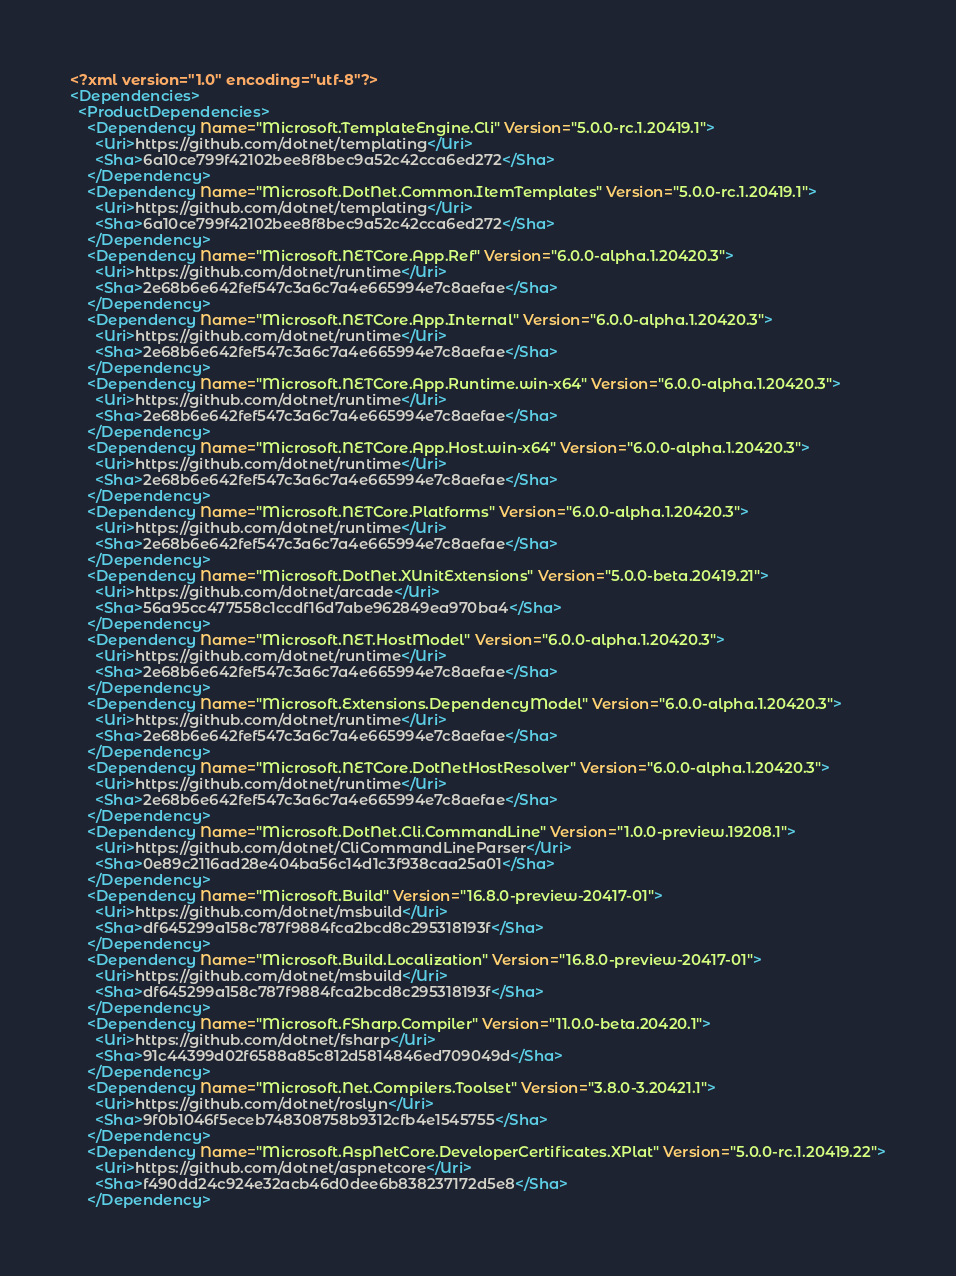<code> <loc_0><loc_0><loc_500><loc_500><_XML_><?xml version="1.0" encoding="utf-8"?>
<Dependencies>
  <ProductDependencies>
    <Dependency Name="Microsoft.TemplateEngine.Cli" Version="5.0.0-rc.1.20419.1">
      <Uri>https://github.com/dotnet/templating</Uri>
      <Sha>6a10ce799f42102bee8f8bec9a52c42cca6ed272</Sha>
    </Dependency>
    <Dependency Name="Microsoft.DotNet.Common.ItemTemplates" Version="5.0.0-rc.1.20419.1">
      <Uri>https://github.com/dotnet/templating</Uri>
      <Sha>6a10ce799f42102bee8f8bec9a52c42cca6ed272</Sha>
    </Dependency>
    <Dependency Name="Microsoft.NETCore.App.Ref" Version="6.0.0-alpha.1.20420.3">
      <Uri>https://github.com/dotnet/runtime</Uri>
      <Sha>2e68b6e642fef547c3a6c7a4e665994e7c8aefae</Sha>
    </Dependency>
    <Dependency Name="Microsoft.NETCore.App.Internal" Version="6.0.0-alpha.1.20420.3">
      <Uri>https://github.com/dotnet/runtime</Uri>
      <Sha>2e68b6e642fef547c3a6c7a4e665994e7c8aefae</Sha>
    </Dependency>
    <Dependency Name="Microsoft.NETCore.App.Runtime.win-x64" Version="6.0.0-alpha.1.20420.3">
      <Uri>https://github.com/dotnet/runtime</Uri>
      <Sha>2e68b6e642fef547c3a6c7a4e665994e7c8aefae</Sha>
    </Dependency>
    <Dependency Name="Microsoft.NETCore.App.Host.win-x64" Version="6.0.0-alpha.1.20420.3">
      <Uri>https://github.com/dotnet/runtime</Uri>
      <Sha>2e68b6e642fef547c3a6c7a4e665994e7c8aefae</Sha>
    </Dependency>
    <Dependency Name="Microsoft.NETCore.Platforms" Version="6.0.0-alpha.1.20420.3">
      <Uri>https://github.com/dotnet/runtime</Uri>
      <Sha>2e68b6e642fef547c3a6c7a4e665994e7c8aefae</Sha>
    </Dependency>
    <Dependency Name="Microsoft.DotNet.XUnitExtensions" Version="5.0.0-beta.20419.21">
      <Uri>https://github.com/dotnet/arcade</Uri>
      <Sha>56a95cc477558c1ccdf16d7abe962849ea970ba4</Sha>
    </Dependency>
    <Dependency Name="Microsoft.NET.HostModel" Version="6.0.0-alpha.1.20420.3">
      <Uri>https://github.com/dotnet/runtime</Uri>
      <Sha>2e68b6e642fef547c3a6c7a4e665994e7c8aefae</Sha>
    </Dependency>
    <Dependency Name="Microsoft.Extensions.DependencyModel" Version="6.0.0-alpha.1.20420.3">
      <Uri>https://github.com/dotnet/runtime</Uri>
      <Sha>2e68b6e642fef547c3a6c7a4e665994e7c8aefae</Sha>
    </Dependency>
    <Dependency Name="Microsoft.NETCore.DotNetHostResolver" Version="6.0.0-alpha.1.20420.3">
      <Uri>https://github.com/dotnet/runtime</Uri>
      <Sha>2e68b6e642fef547c3a6c7a4e665994e7c8aefae</Sha>
    </Dependency>
    <Dependency Name="Microsoft.DotNet.Cli.CommandLine" Version="1.0.0-preview.19208.1">
      <Uri>https://github.com/dotnet/CliCommandLineParser</Uri>
      <Sha>0e89c2116ad28e404ba56c14d1c3f938caa25a01</Sha>
    </Dependency>
    <Dependency Name="Microsoft.Build" Version="16.8.0-preview-20417-01">
      <Uri>https://github.com/dotnet/msbuild</Uri>
      <Sha>df645299a158c787f9884fca2bcd8c295318193f</Sha>
    </Dependency>
    <Dependency Name="Microsoft.Build.Localization" Version="16.8.0-preview-20417-01">
      <Uri>https://github.com/dotnet/msbuild</Uri>
      <Sha>df645299a158c787f9884fca2bcd8c295318193f</Sha>
    </Dependency>
    <Dependency Name="Microsoft.FSharp.Compiler" Version="11.0.0-beta.20420.1">
      <Uri>https://github.com/dotnet/fsharp</Uri>
      <Sha>91c44399d02f6588a85c812d5814846ed709049d</Sha>
    </Dependency>
    <Dependency Name="Microsoft.Net.Compilers.Toolset" Version="3.8.0-3.20421.1">
      <Uri>https://github.com/dotnet/roslyn</Uri>
      <Sha>9f0b1046f5eceb748308758b9312cfb4e1545755</Sha>
    </Dependency>
    <Dependency Name="Microsoft.AspNetCore.DeveloperCertificates.XPlat" Version="5.0.0-rc.1.20419.22">
      <Uri>https://github.com/dotnet/aspnetcore</Uri>
      <Sha>f490dd24c924e32acb46d0dee6b838237172d5e8</Sha>
    </Dependency></code> 